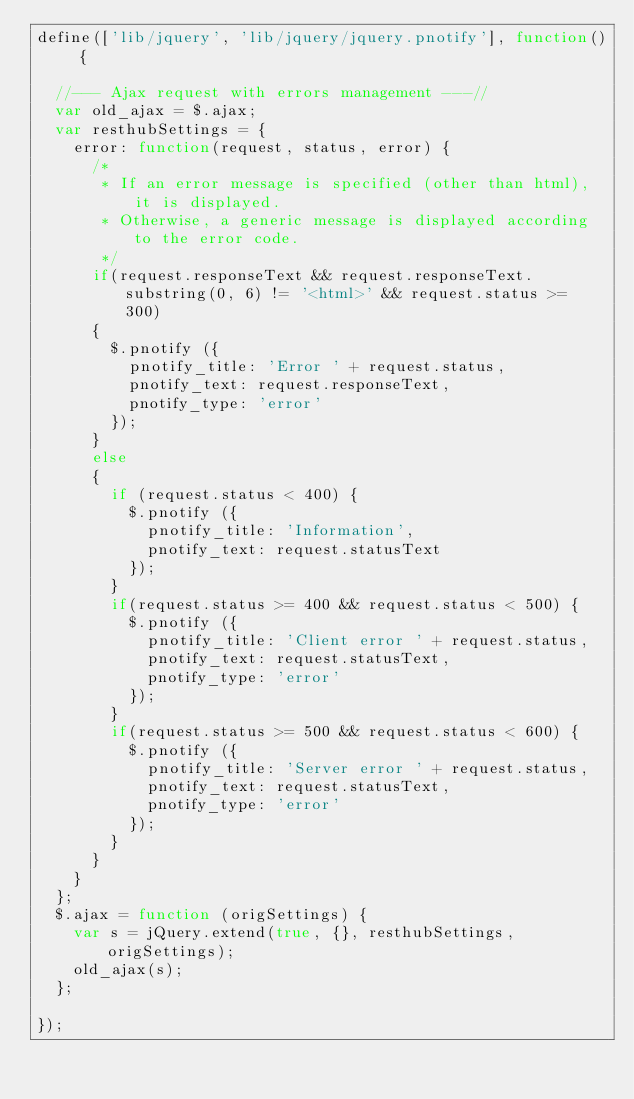Convert code to text. <code><loc_0><loc_0><loc_500><loc_500><_JavaScript_>define(['lib/jquery', 'lib/jquery/jquery.pnotify'], function() {

	//--- Ajax request with errors management ---//
	var old_ajax = $.ajax;
	var resthubSettings = {
		error: function(request, status, error) {
			/*
			 * If an error message is specified (other than html), it is displayed.
			 * Otherwise, a generic message is displayed according to the error code.
			 */
			if(request.responseText && request.responseText.substring(0, 6) != '<html>' && request.status >= 300)
			{
				$.pnotify ({
					pnotify_title: 'Error ' + request.status,
					pnotify_text: request.responseText,
					pnotify_type: 'error'
				});
			}
			else
			{
				if (request.status < 400) {
					$.pnotify ({
						pnotify_title: 'Information',
						pnotify_text: request.statusText
					});
				}
				if(request.status >= 400 && request.status < 500) {
					$.pnotify ({
						pnotify_title: 'Client error ' + request.status,
						pnotify_text: request.statusText,
						pnotify_type: 'error'
					});
				}
				if(request.status >= 500 && request.status < 600) {
					$.pnotify ({
						pnotify_title: 'Server error ' + request.status,
						pnotify_text: request.statusText,
						pnotify_type: 'error'
					});
				}
			}
		}
	};
	$.ajax = function (origSettings) {
		var s = jQuery.extend(true, {}, resthubSettings, origSettings);
		old_ajax(s);
	};

});</code> 